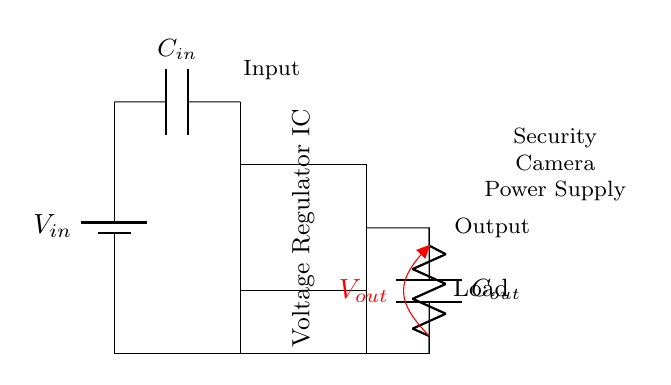What is the input voltage value? The input voltage is labeled as V_in in the circuit diagram, which indicates the voltage sourced to the circuit. Since the diagram doesn't provide a numerical value, we can't specify a number.
Answer: V_in What component is used for input filtering? The circuit includes a capacitor labeled as C_in connected across the input voltage source, which serves to filter any noise and stabilize the voltage before it enters the voltage regulator.
Answer: C_in What type of component is used as the load? The circuit shows a resistor labeled as Load, indicating that it acts as a loading element that consumes the output power from the voltage regulator.
Answer: Load Where is the output voltage taken? The output voltage, labeled as V_out, is taken at the output terminal of the voltage regulator, specifically at the point where it connects to the load and the output capacitor.
Answer: V_out What is the purpose of the voltage regulator IC? The voltage regulator IC is designed to regulate or maintain a stable output voltage despite variations in input voltage or load conditions, ensuring reliable power supply to the connected devices (security cameras).
Answer: Stabilization How many capacitors are present in the circuit? The diagram shows two capacitors: C_in for input filtering and C_out for output smoothing. This helps in controlling voltage fluctuations and improving overall efficiency.
Answer: Two 